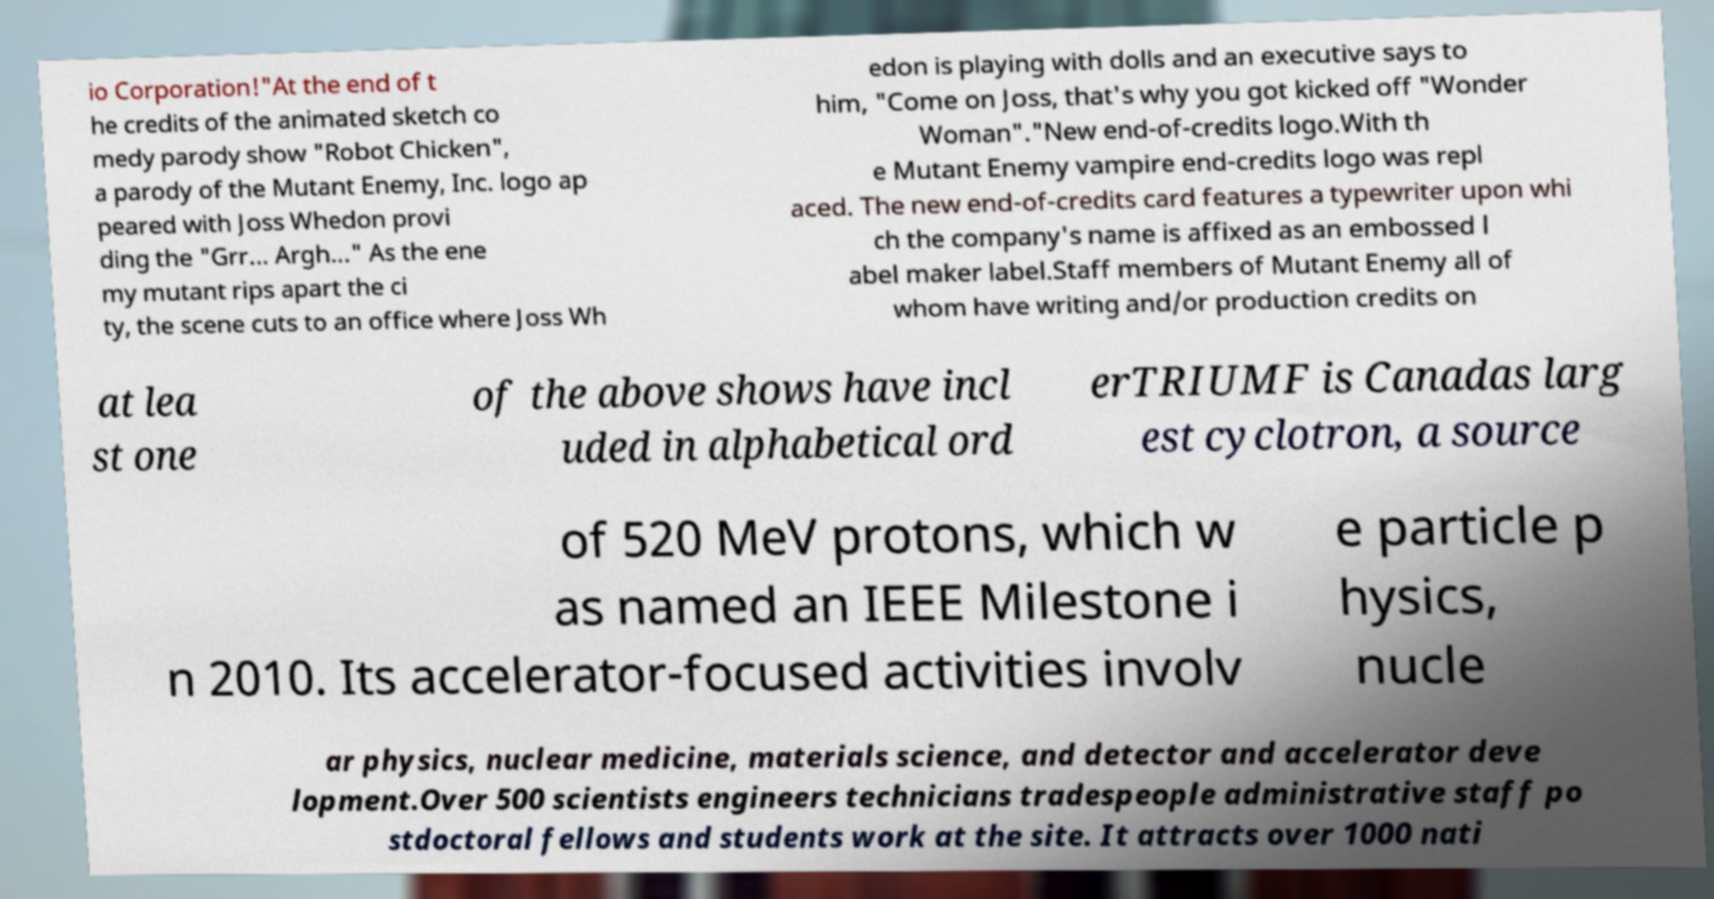For documentation purposes, I need the text within this image transcribed. Could you provide that? io Corporation!"At the end of t he credits of the animated sketch co medy parody show "Robot Chicken", a parody of the Mutant Enemy, Inc. logo ap peared with Joss Whedon provi ding the "Grr... Argh..." As the ene my mutant rips apart the ci ty, the scene cuts to an office where Joss Wh edon is playing with dolls and an executive says to him, "Come on Joss, that's why you got kicked off "Wonder Woman"."New end-of-credits logo.With th e Mutant Enemy vampire end-credits logo was repl aced. The new end-of-credits card features a typewriter upon whi ch the company's name is affixed as an embossed l abel maker label.Staff members of Mutant Enemy all of whom have writing and/or production credits on at lea st one of the above shows have incl uded in alphabetical ord erTRIUMF is Canadas larg est cyclotron, a source of 520 MeV protons, which w as named an IEEE Milestone i n 2010. Its accelerator-focused activities involv e particle p hysics, nucle ar physics, nuclear medicine, materials science, and detector and accelerator deve lopment.Over 500 scientists engineers technicians tradespeople administrative staff po stdoctoral fellows and students work at the site. It attracts over 1000 nati 